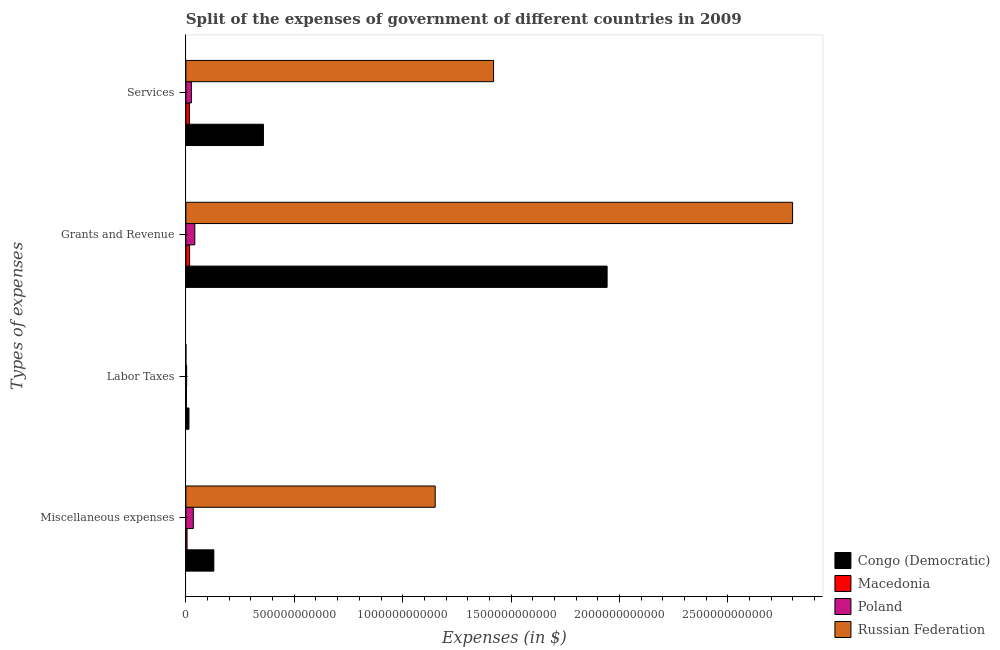How many bars are there on the 4th tick from the top?
Give a very brief answer. 4. How many bars are there on the 1st tick from the bottom?
Ensure brevity in your answer.  4. What is the label of the 2nd group of bars from the top?
Your answer should be very brief. Grants and Revenue. Across all countries, what is the maximum amount spent on miscellaneous expenses?
Keep it short and to the point. 1.15e+12. Across all countries, what is the minimum amount spent on grants and revenue?
Provide a succinct answer. 1.72e+1. In which country was the amount spent on labor taxes maximum?
Your response must be concise. Congo (Democratic). What is the total amount spent on miscellaneous expenses in the graph?
Provide a short and direct response. 1.32e+12. What is the difference between the amount spent on grants and revenue in Congo (Democratic) and that in Poland?
Offer a very short reply. 1.90e+12. What is the difference between the amount spent on services in Macedonia and the amount spent on grants and revenue in Poland?
Your response must be concise. -2.49e+1. What is the average amount spent on miscellaneous expenses per country?
Your answer should be very brief. 3.30e+11. What is the difference between the amount spent on grants and revenue and amount spent on miscellaneous expenses in Russian Federation?
Keep it short and to the point. 1.65e+12. What is the ratio of the amount spent on miscellaneous expenses in Macedonia to that in Russian Federation?
Your answer should be very brief. 0. Is the amount spent on miscellaneous expenses in Poland less than that in Macedonia?
Provide a succinct answer. No. What is the difference between the highest and the second highest amount spent on labor taxes?
Provide a succinct answer. 1.07e+1. What is the difference between the highest and the lowest amount spent on labor taxes?
Ensure brevity in your answer.  1.42e+1. Is the sum of the amount spent on services in Russian Federation and Macedonia greater than the maximum amount spent on miscellaneous expenses across all countries?
Ensure brevity in your answer.  Yes. Is it the case that in every country, the sum of the amount spent on miscellaneous expenses and amount spent on labor taxes is greater than the amount spent on grants and revenue?
Offer a very short reply. No. How many countries are there in the graph?
Your response must be concise. 4. What is the difference between two consecutive major ticks on the X-axis?
Your answer should be compact. 5.00e+11. Does the graph contain any zero values?
Keep it short and to the point. Yes. Where does the legend appear in the graph?
Offer a very short reply. Bottom right. How many legend labels are there?
Provide a short and direct response. 4. What is the title of the graph?
Give a very brief answer. Split of the expenses of government of different countries in 2009. What is the label or title of the X-axis?
Keep it short and to the point. Expenses (in $). What is the label or title of the Y-axis?
Offer a very short reply. Types of expenses. What is the Expenses (in $) in Congo (Democratic) in Miscellaneous expenses?
Make the answer very short. 1.29e+11. What is the Expenses (in $) of Macedonia in Miscellaneous expenses?
Keep it short and to the point. 5.48e+09. What is the Expenses (in $) in Poland in Miscellaneous expenses?
Provide a short and direct response. 3.42e+1. What is the Expenses (in $) of Russian Federation in Miscellaneous expenses?
Provide a succinct answer. 1.15e+12. What is the Expenses (in $) of Congo (Democratic) in Labor Taxes?
Your response must be concise. 1.42e+1. What is the Expenses (in $) in Macedonia in Labor Taxes?
Your response must be concise. 2.68e+09. What is the Expenses (in $) of Poland in Labor Taxes?
Offer a very short reply. 3.54e+09. What is the Expenses (in $) in Russian Federation in Labor Taxes?
Keep it short and to the point. 0. What is the Expenses (in $) of Congo (Democratic) in Grants and Revenue?
Make the answer very short. 1.94e+12. What is the Expenses (in $) of Macedonia in Grants and Revenue?
Your answer should be very brief. 1.72e+1. What is the Expenses (in $) in Poland in Grants and Revenue?
Provide a short and direct response. 4.11e+1. What is the Expenses (in $) of Russian Federation in Grants and Revenue?
Offer a terse response. 2.80e+12. What is the Expenses (in $) of Congo (Democratic) in Services?
Give a very brief answer. 3.58e+11. What is the Expenses (in $) of Macedonia in Services?
Your answer should be compact. 1.62e+1. What is the Expenses (in $) in Poland in Services?
Your response must be concise. 2.54e+1. What is the Expenses (in $) in Russian Federation in Services?
Offer a very short reply. 1.42e+12. Across all Types of expenses, what is the maximum Expenses (in $) of Congo (Democratic)?
Your answer should be very brief. 1.94e+12. Across all Types of expenses, what is the maximum Expenses (in $) in Macedonia?
Make the answer very short. 1.72e+1. Across all Types of expenses, what is the maximum Expenses (in $) in Poland?
Provide a short and direct response. 4.11e+1. Across all Types of expenses, what is the maximum Expenses (in $) of Russian Federation?
Keep it short and to the point. 2.80e+12. Across all Types of expenses, what is the minimum Expenses (in $) of Congo (Democratic)?
Your response must be concise. 1.42e+1. Across all Types of expenses, what is the minimum Expenses (in $) in Macedonia?
Give a very brief answer. 2.68e+09. Across all Types of expenses, what is the minimum Expenses (in $) of Poland?
Ensure brevity in your answer.  3.54e+09. Across all Types of expenses, what is the minimum Expenses (in $) of Russian Federation?
Keep it short and to the point. 0. What is the total Expenses (in $) of Congo (Democratic) in the graph?
Your answer should be compact. 2.44e+12. What is the total Expenses (in $) of Macedonia in the graph?
Provide a short and direct response. 4.16e+1. What is the total Expenses (in $) in Poland in the graph?
Provide a short and direct response. 1.04e+11. What is the total Expenses (in $) of Russian Federation in the graph?
Ensure brevity in your answer.  5.37e+12. What is the difference between the Expenses (in $) of Congo (Democratic) in Miscellaneous expenses and that in Labor Taxes?
Your response must be concise. 1.15e+11. What is the difference between the Expenses (in $) in Macedonia in Miscellaneous expenses and that in Labor Taxes?
Provide a short and direct response. 2.80e+09. What is the difference between the Expenses (in $) in Poland in Miscellaneous expenses and that in Labor Taxes?
Offer a very short reply. 3.07e+1. What is the difference between the Expenses (in $) in Congo (Democratic) in Miscellaneous expenses and that in Grants and Revenue?
Keep it short and to the point. -1.81e+12. What is the difference between the Expenses (in $) of Macedonia in Miscellaneous expenses and that in Grants and Revenue?
Make the answer very short. -1.18e+1. What is the difference between the Expenses (in $) in Poland in Miscellaneous expenses and that in Grants and Revenue?
Your answer should be very brief. -6.89e+09. What is the difference between the Expenses (in $) of Russian Federation in Miscellaneous expenses and that in Grants and Revenue?
Your response must be concise. -1.65e+12. What is the difference between the Expenses (in $) in Congo (Democratic) in Miscellaneous expenses and that in Services?
Offer a very short reply. -2.29e+11. What is the difference between the Expenses (in $) in Macedonia in Miscellaneous expenses and that in Services?
Your answer should be compact. -1.07e+1. What is the difference between the Expenses (in $) of Poland in Miscellaneous expenses and that in Services?
Offer a terse response. 8.83e+09. What is the difference between the Expenses (in $) of Russian Federation in Miscellaneous expenses and that in Services?
Your answer should be very brief. -2.69e+11. What is the difference between the Expenses (in $) in Congo (Democratic) in Labor Taxes and that in Grants and Revenue?
Keep it short and to the point. -1.93e+12. What is the difference between the Expenses (in $) of Macedonia in Labor Taxes and that in Grants and Revenue?
Your answer should be compact. -1.46e+1. What is the difference between the Expenses (in $) in Poland in Labor Taxes and that in Grants and Revenue?
Ensure brevity in your answer.  -3.76e+1. What is the difference between the Expenses (in $) in Congo (Democratic) in Labor Taxes and that in Services?
Make the answer very short. -3.43e+11. What is the difference between the Expenses (in $) in Macedonia in Labor Taxes and that in Services?
Offer a very short reply. -1.35e+1. What is the difference between the Expenses (in $) of Poland in Labor Taxes and that in Services?
Ensure brevity in your answer.  -2.19e+1. What is the difference between the Expenses (in $) in Congo (Democratic) in Grants and Revenue and that in Services?
Keep it short and to the point. 1.59e+12. What is the difference between the Expenses (in $) in Macedonia in Grants and Revenue and that in Services?
Provide a short and direct response. 1.01e+09. What is the difference between the Expenses (in $) in Poland in Grants and Revenue and that in Services?
Offer a very short reply. 1.57e+1. What is the difference between the Expenses (in $) of Russian Federation in Grants and Revenue and that in Services?
Make the answer very short. 1.38e+12. What is the difference between the Expenses (in $) in Congo (Democratic) in Miscellaneous expenses and the Expenses (in $) in Macedonia in Labor Taxes?
Provide a succinct answer. 1.26e+11. What is the difference between the Expenses (in $) of Congo (Democratic) in Miscellaneous expenses and the Expenses (in $) of Poland in Labor Taxes?
Give a very brief answer. 1.25e+11. What is the difference between the Expenses (in $) in Macedonia in Miscellaneous expenses and the Expenses (in $) in Poland in Labor Taxes?
Your answer should be very brief. 1.94e+09. What is the difference between the Expenses (in $) of Congo (Democratic) in Miscellaneous expenses and the Expenses (in $) of Macedonia in Grants and Revenue?
Offer a terse response. 1.12e+11. What is the difference between the Expenses (in $) of Congo (Democratic) in Miscellaneous expenses and the Expenses (in $) of Poland in Grants and Revenue?
Your answer should be compact. 8.79e+1. What is the difference between the Expenses (in $) of Congo (Democratic) in Miscellaneous expenses and the Expenses (in $) of Russian Federation in Grants and Revenue?
Offer a terse response. -2.67e+12. What is the difference between the Expenses (in $) in Macedonia in Miscellaneous expenses and the Expenses (in $) in Poland in Grants and Revenue?
Provide a short and direct response. -3.57e+1. What is the difference between the Expenses (in $) of Macedonia in Miscellaneous expenses and the Expenses (in $) of Russian Federation in Grants and Revenue?
Your answer should be compact. -2.79e+12. What is the difference between the Expenses (in $) of Poland in Miscellaneous expenses and the Expenses (in $) of Russian Federation in Grants and Revenue?
Offer a terse response. -2.76e+12. What is the difference between the Expenses (in $) of Congo (Democratic) in Miscellaneous expenses and the Expenses (in $) of Macedonia in Services?
Ensure brevity in your answer.  1.13e+11. What is the difference between the Expenses (in $) in Congo (Democratic) in Miscellaneous expenses and the Expenses (in $) in Poland in Services?
Your answer should be very brief. 1.04e+11. What is the difference between the Expenses (in $) in Congo (Democratic) in Miscellaneous expenses and the Expenses (in $) in Russian Federation in Services?
Ensure brevity in your answer.  -1.29e+12. What is the difference between the Expenses (in $) in Macedonia in Miscellaneous expenses and the Expenses (in $) in Poland in Services?
Ensure brevity in your answer.  -1.99e+1. What is the difference between the Expenses (in $) in Macedonia in Miscellaneous expenses and the Expenses (in $) in Russian Federation in Services?
Your answer should be very brief. -1.41e+12. What is the difference between the Expenses (in $) in Poland in Miscellaneous expenses and the Expenses (in $) in Russian Federation in Services?
Provide a short and direct response. -1.38e+12. What is the difference between the Expenses (in $) of Congo (Democratic) in Labor Taxes and the Expenses (in $) of Macedonia in Grants and Revenue?
Your answer should be compact. -3.03e+09. What is the difference between the Expenses (in $) in Congo (Democratic) in Labor Taxes and the Expenses (in $) in Poland in Grants and Revenue?
Offer a terse response. -2.69e+1. What is the difference between the Expenses (in $) in Congo (Democratic) in Labor Taxes and the Expenses (in $) in Russian Federation in Grants and Revenue?
Give a very brief answer. -2.78e+12. What is the difference between the Expenses (in $) of Macedonia in Labor Taxes and the Expenses (in $) of Poland in Grants and Revenue?
Offer a terse response. -3.85e+1. What is the difference between the Expenses (in $) in Macedonia in Labor Taxes and the Expenses (in $) in Russian Federation in Grants and Revenue?
Your response must be concise. -2.80e+12. What is the difference between the Expenses (in $) of Poland in Labor Taxes and the Expenses (in $) of Russian Federation in Grants and Revenue?
Your answer should be very brief. -2.79e+12. What is the difference between the Expenses (in $) of Congo (Democratic) in Labor Taxes and the Expenses (in $) of Macedonia in Services?
Offer a terse response. -2.02e+09. What is the difference between the Expenses (in $) in Congo (Democratic) in Labor Taxes and the Expenses (in $) in Poland in Services?
Offer a terse response. -1.12e+1. What is the difference between the Expenses (in $) in Congo (Democratic) in Labor Taxes and the Expenses (in $) in Russian Federation in Services?
Ensure brevity in your answer.  -1.40e+12. What is the difference between the Expenses (in $) in Macedonia in Labor Taxes and the Expenses (in $) in Poland in Services?
Offer a terse response. -2.27e+1. What is the difference between the Expenses (in $) in Macedonia in Labor Taxes and the Expenses (in $) in Russian Federation in Services?
Your answer should be compact. -1.42e+12. What is the difference between the Expenses (in $) in Poland in Labor Taxes and the Expenses (in $) in Russian Federation in Services?
Your answer should be compact. -1.42e+12. What is the difference between the Expenses (in $) of Congo (Democratic) in Grants and Revenue and the Expenses (in $) of Macedonia in Services?
Ensure brevity in your answer.  1.93e+12. What is the difference between the Expenses (in $) in Congo (Democratic) in Grants and Revenue and the Expenses (in $) in Poland in Services?
Give a very brief answer. 1.92e+12. What is the difference between the Expenses (in $) of Congo (Democratic) in Grants and Revenue and the Expenses (in $) of Russian Federation in Services?
Your answer should be very brief. 5.24e+11. What is the difference between the Expenses (in $) of Macedonia in Grants and Revenue and the Expenses (in $) of Poland in Services?
Your response must be concise. -8.18e+09. What is the difference between the Expenses (in $) in Macedonia in Grants and Revenue and the Expenses (in $) in Russian Federation in Services?
Keep it short and to the point. -1.40e+12. What is the difference between the Expenses (in $) in Poland in Grants and Revenue and the Expenses (in $) in Russian Federation in Services?
Ensure brevity in your answer.  -1.38e+12. What is the average Expenses (in $) of Congo (Democratic) per Types of expenses?
Keep it short and to the point. 6.11e+11. What is the average Expenses (in $) of Macedonia per Types of expenses?
Your response must be concise. 1.04e+1. What is the average Expenses (in $) in Poland per Types of expenses?
Make the answer very short. 2.61e+1. What is the average Expenses (in $) in Russian Federation per Types of expenses?
Provide a short and direct response. 1.34e+12. What is the difference between the Expenses (in $) in Congo (Democratic) and Expenses (in $) in Macedonia in Miscellaneous expenses?
Ensure brevity in your answer.  1.24e+11. What is the difference between the Expenses (in $) in Congo (Democratic) and Expenses (in $) in Poland in Miscellaneous expenses?
Your response must be concise. 9.48e+1. What is the difference between the Expenses (in $) of Congo (Democratic) and Expenses (in $) of Russian Federation in Miscellaneous expenses?
Offer a terse response. -1.02e+12. What is the difference between the Expenses (in $) in Macedonia and Expenses (in $) in Poland in Miscellaneous expenses?
Make the answer very short. -2.88e+1. What is the difference between the Expenses (in $) of Macedonia and Expenses (in $) of Russian Federation in Miscellaneous expenses?
Give a very brief answer. -1.14e+12. What is the difference between the Expenses (in $) of Poland and Expenses (in $) of Russian Federation in Miscellaneous expenses?
Give a very brief answer. -1.12e+12. What is the difference between the Expenses (in $) in Congo (Democratic) and Expenses (in $) in Macedonia in Labor Taxes?
Offer a very short reply. 1.15e+1. What is the difference between the Expenses (in $) in Congo (Democratic) and Expenses (in $) in Poland in Labor Taxes?
Keep it short and to the point. 1.07e+1. What is the difference between the Expenses (in $) in Macedonia and Expenses (in $) in Poland in Labor Taxes?
Make the answer very short. -8.65e+08. What is the difference between the Expenses (in $) of Congo (Democratic) and Expenses (in $) of Macedonia in Grants and Revenue?
Offer a terse response. 1.93e+12. What is the difference between the Expenses (in $) in Congo (Democratic) and Expenses (in $) in Poland in Grants and Revenue?
Your answer should be very brief. 1.90e+12. What is the difference between the Expenses (in $) in Congo (Democratic) and Expenses (in $) in Russian Federation in Grants and Revenue?
Your answer should be compact. -8.55e+11. What is the difference between the Expenses (in $) of Macedonia and Expenses (in $) of Poland in Grants and Revenue?
Keep it short and to the point. -2.39e+1. What is the difference between the Expenses (in $) in Macedonia and Expenses (in $) in Russian Federation in Grants and Revenue?
Make the answer very short. -2.78e+12. What is the difference between the Expenses (in $) of Poland and Expenses (in $) of Russian Federation in Grants and Revenue?
Provide a short and direct response. -2.76e+12. What is the difference between the Expenses (in $) of Congo (Democratic) and Expenses (in $) of Macedonia in Services?
Your answer should be compact. 3.41e+11. What is the difference between the Expenses (in $) of Congo (Democratic) and Expenses (in $) of Poland in Services?
Provide a succinct answer. 3.32e+11. What is the difference between the Expenses (in $) of Congo (Democratic) and Expenses (in $) of Russian Federation in Services?
Offer a very short reply. -1.06e+12. What is the difference between the Expenses (in $) of Macedonia and Expenses (in $) of Poland in Services?
Provide a short and direct response. -9.20e+09. What is the difference between the Expenses (in $) in Macedonia and Expenses (in $) in Russian Federation in Services?
Make the answer very short. -1.40e+12. What is the difference between the Expenses (in $) in Poland and Expenses (in $) in Russian Federation in Services?
Your answer should be compact. -1.39e+12. What is the ratio of the Expenses (in $) of Congo (Democratic) in Miscellaneous expenses to that in Labor Taxes?
Your answer should be very brief. 9.08. What is the ratio of the Expenses (in $) in Macedonia in Miscellaneous expenses to that in Labor Taxes?
Provide a succinct answer. 2.05. What is the ratio of the Expenses (in $) of Poland in Miscellaneous expenses to that in Labor Taxes?
Ensure brevity in your answer.  9.67. What is the ratio of the Expenses (in $) in Congo (Democratic) in Miscellaneous expenses to that in Grants and Revenue?
Give a very brief answer. 0.07. What is the ratio of the Expenses (in $) in Macedonia in Miscellaneous expenses to that in Grants and Revenue?
Give a very brief answer. 0.32. What is the ratio of the Expenses (in $) of Poland in Miscellaneous expenses to that in Grants and Revenue?
Give a very brief answer. 0.83. What is the ratio of the Expenses (in $) in Russian Federation in Miscellaneous expenses to that in Grants and Revenue?
Ensure brevity in your answer.  0.41. What is the ratio of the Expenses (in $) of Congo (Democratic) in Miscellaneous expenses to that in Services?
Offer a terse response. 0.36. What is the ratio of the Expenses (in $) in Macedonia in Miscellaneous expenses to that in Services?
Your answer should be very brief. 0.34. What is the ratio of the Expenses (in $) in Poland in Miscellaneous expenses to that in Services?
Your answer should be compact. 1.35. What is the ratio of the Expenses (in $) in Russian Federation in Miscellaneous expenses to that in Services?
Give a very brief answer. 0.81. What is the ratio of the Expenses (in $) in Congo (Democratic) in Labor Taxes to that in Grants and Revenue?
Make the answer very short. 0.01. What is the ratio of the Expenses (in $) of Macedonia in Labor Taxes to that in Grants and Revenue?
Make the answer very short. 0.16. What is the ratio of the Expenses (in $) in Poland in Labor Taxes to that in Grants and Revenue?
Give a very brief answer. 0.09. What is the ratio of the Expenses (in $) in Congo (Democratic) in Labor Taxes to that in Services?
Your answer should be very brief. 0.04. What is the ratio of the Expenses (in $) of Macedonia in Labor Taxes to that in Services?
Your answer should be compact. 0.16. What is the ratio of the Expenses (in $) of Poland in Labor Taxes to that in Services?
Your answer should be compact. 0.14. What is the ratio of the Expenses (in $) in Congo (Democratic) in Grants and Revenue to that in Services?
Make the answer very short. 5.43. What is the ratio of the Expenses (in $) in Poland in Grants and Revenue to that in Services?
Your response must be concise. 1.62. What is the ratio of the Expenses (in $) of Russian Federation in Grants and Revenue to that in Services?
Your answer should be very brief. 1.97. What is the difference between the highest and the second highest Expenses (in $) in Congo (Democratic)?
Give a very brief answer. 1.59e+12. What is the difference between the highest and the second highest Expenses (in $) of Macedonia?
Offer a terse response. 1.01e+09. What is the difference between the highest and the second highest Expenses (in $) in Poland?
Offer a terse response. 6.89e+09. What is the difference between the highest and the second highest Expenses (in $) in Russian Federation?
Provide a succinct answer. 1.38e+12. What is the difference between the highest and the lowest Expenses (in $) in Congo (Democratic)?
Offer a terse response. 1.93e+12. What is the difference between the highest and the lowest Expenses (in $) of Macedonia?
Provide a succinct answer. 1.46e+1. What is the difference between the highest and the lowest Expenses (in $) of Poland?
Keep it short and to the point. 3.76e+1. What is the difference between the highest and the lowest Expenses (in $) of Russian Federation?
Your answer should be very brief. 2.80e+12. 